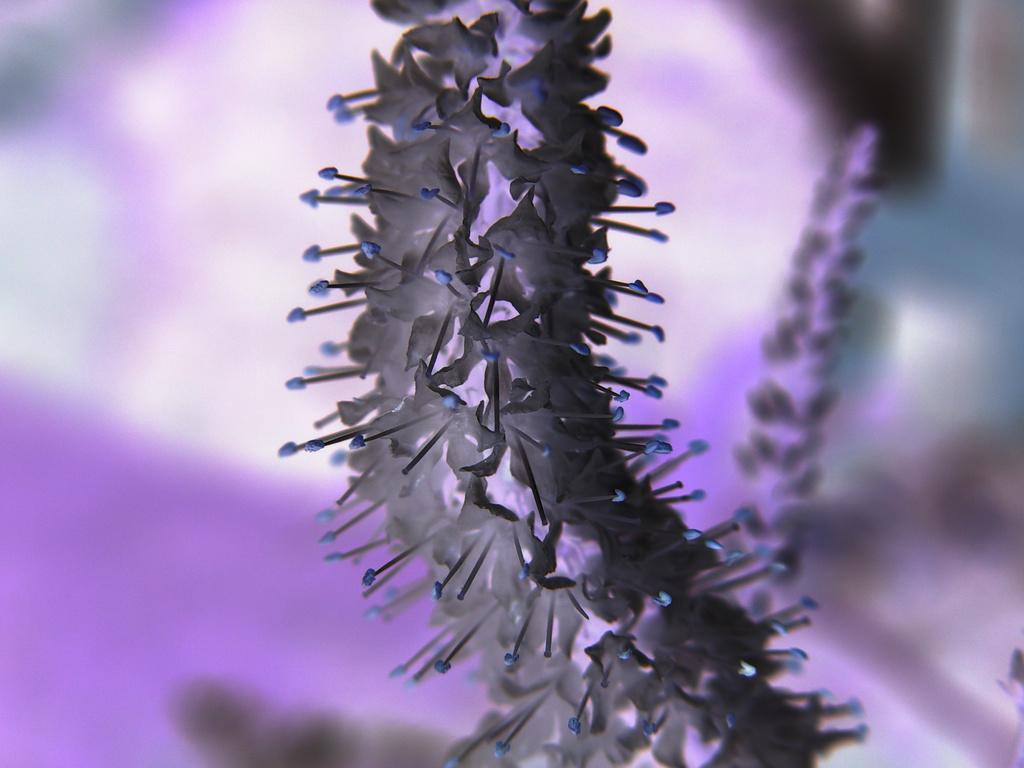Can you describe this image briefly? This is an edited image. The picture consists of flowers. The background is blurred. 